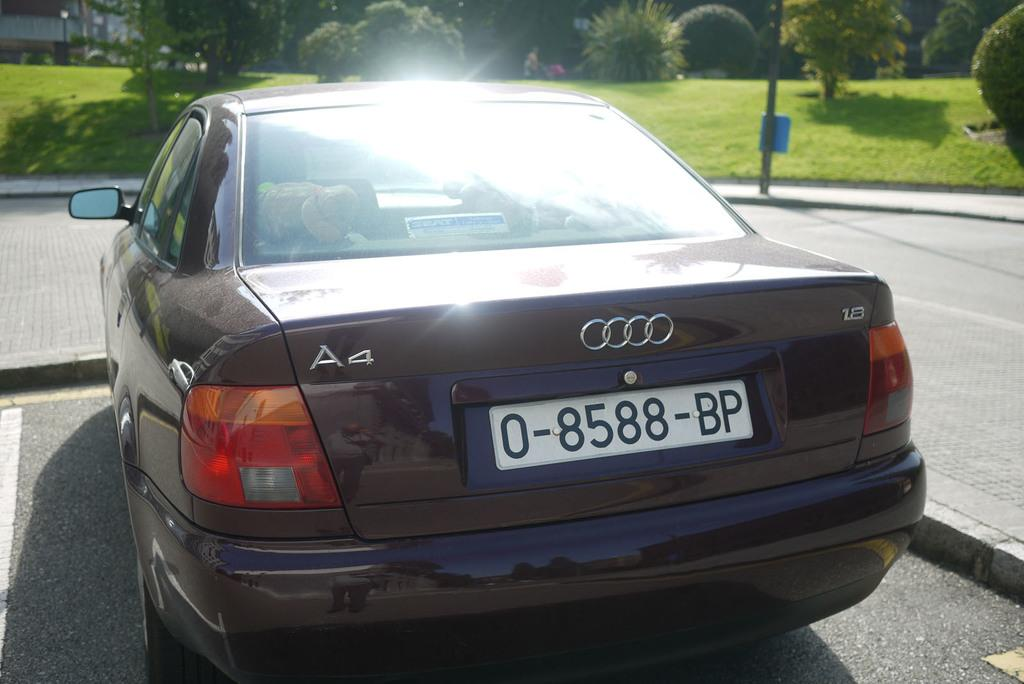<image>
Render a clear and concise summary of the photo. A small brown sedan with A4 on the top left side. 